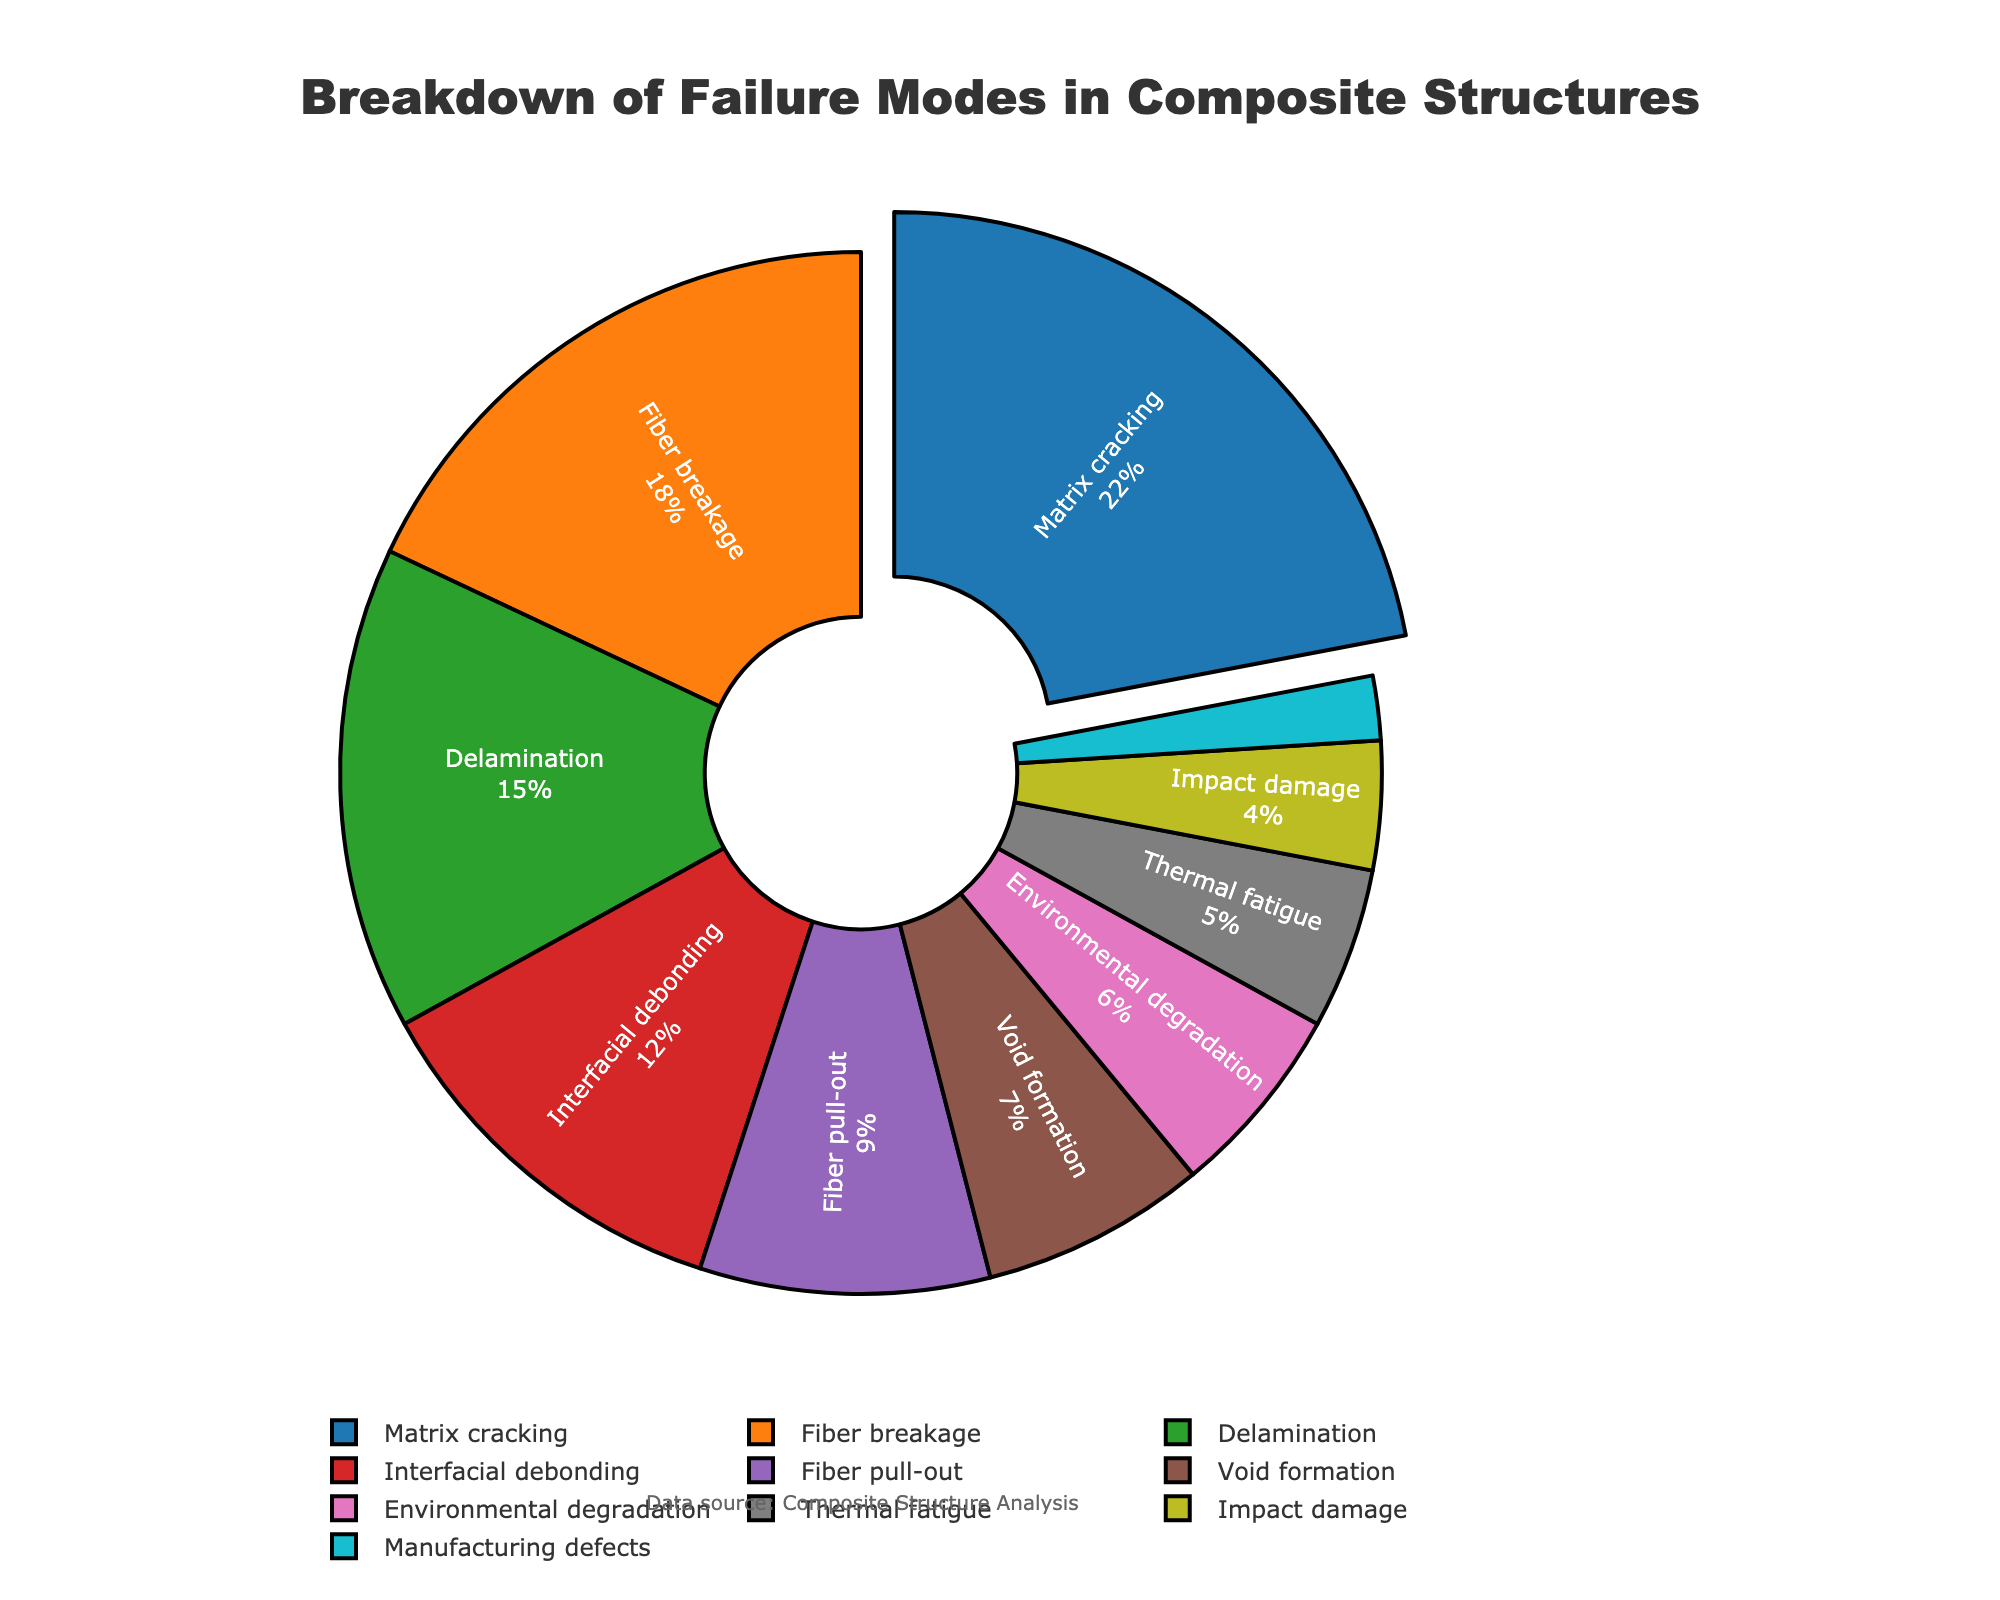Which failure mode accounts for the highest percentage? Matrix cracking accounts for the highest percentage. The figure visually shows that the segment for Matrix cracking is pulled out from the pie to highlight it.
Answer: Matrix cracking What percentage of total failures do Matrix cracking and Fiber breakage together account for? Add the percentages for Matrix cracking (22%) and Fiber breakage (18%). 22 + 18 = 40
Answer: 40% Which failure modes have a percentage greater than or equal to 15%? Locate the segments on the pie chart that have their corresponding percentages labeled as 15% or higher. These are Matrix cracking (22%), Fiber breakage (18%), and Delamination (15%).
Answer: Matrix cracking, Fiber breakage, Delamination Compare the percentage of Fiber pull-out and Void formation. Which one is higher and by how much? Fiber pull-out accounts for 9% and Void formation for 7%. Subtract the smaller percentage from the larger one: 9 - 7 = 2. Fiber pull-out is higher by 2%.
Answer: Fiber pull-out by 2% What is the percentage difference between Environmental degradation and Thermal fatigue? Environmental degradation is 6% and Thermal fatigue is 5%. Subtract the smaller percentage from the larger one: 6 - 5 = 1.
Answer: 1% How many failure modes account for less than or equal to 5% each? Examine the pie chart to identify and count the segments with their percentages labeled as 5% or below. These are Thermal fatigue (5%), Impact damage (4%), and Manufacturing defects (2%).
Answer: 3 What is the total percentage of the least common four failure modes? Identify the four failure modes with the smallest percentages and sum them up. These modes are Environmental degradation (6%), Thermal fatigue (5%), Impact damage (4%), and Manufacturing defects (2%). 6 + 5 + 4 + 2 = 17.
Answer: 17% Which segment is represented with a unique color and what does it represent? The segment pulled out and highlighted with a unique color (blue) represents Matrix cracking, the most significant failure mode.
Answer: Matrix cracking What's the combined percentage of Interfacial debonding, Void formation, and Environmental degradation? Add the percentages of Interfacial debonding (12%), Void formation (7%), and Environmental degradation (6%). 12 + 7 + 6 = 25
Answer: 25% Which failure mode occupies a segment immediately to the right of Fiber breakage in the pie chart? The pie chart should mark the position of each segment. To the immediate right of Fiber breakage (18%) is Delamination (15%).
Answer: Delamination 